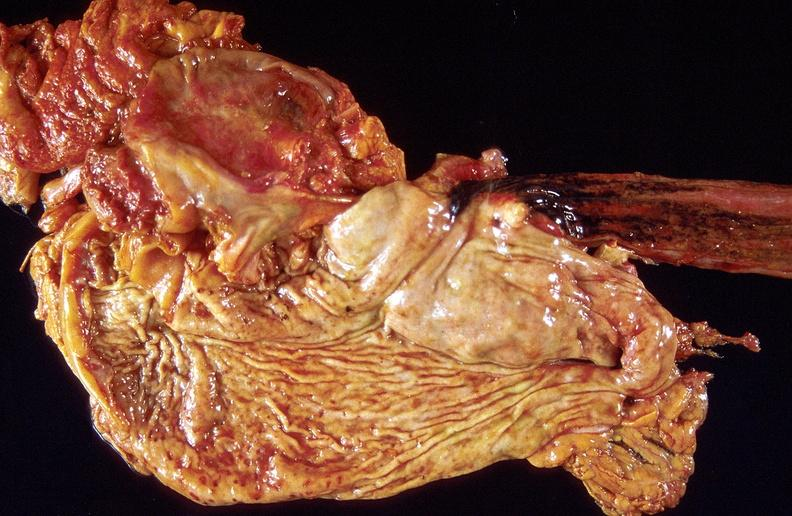what does this image show?
Answer the question using a single word or phrase. Stress ulcers 